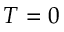Convert formula to latex. <formula><loc_0><loc_0><loc_500><loc_500>T = 0</formula> 